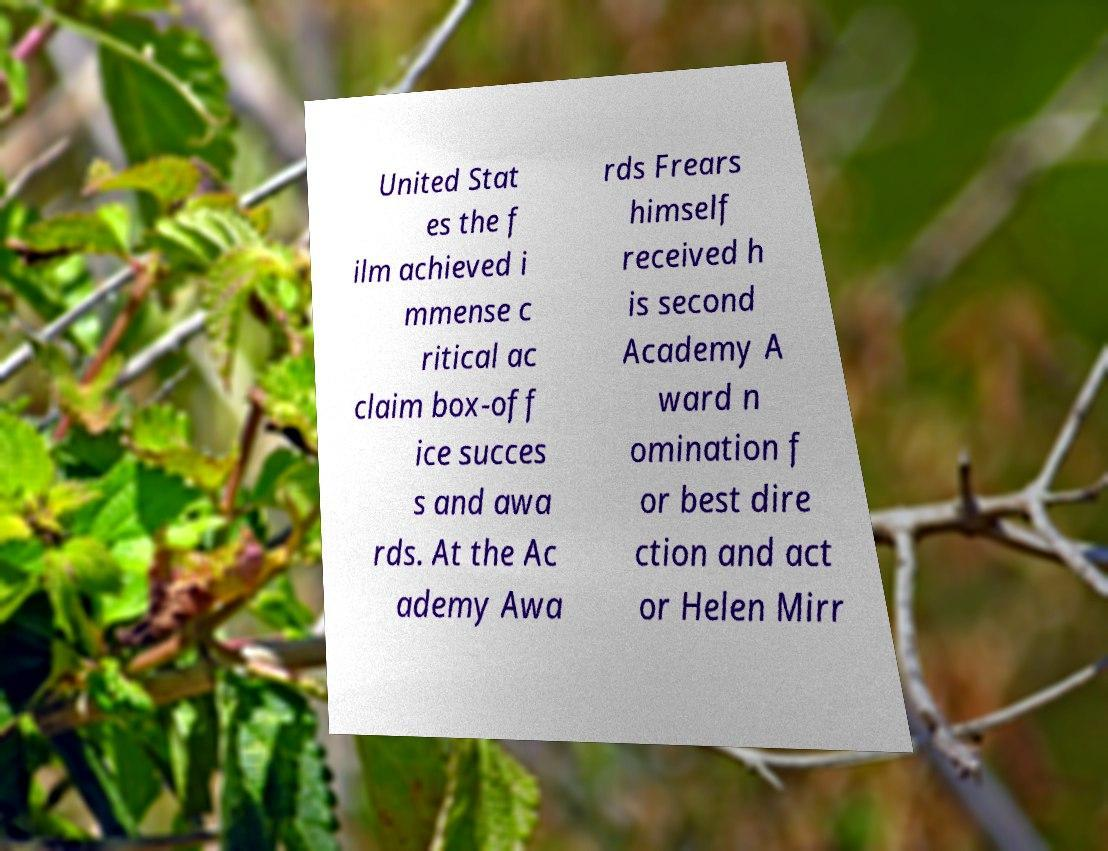Can you accurately transcribe the text from the provided image for me? United Stat es the f ilm achieved i mmense c ritical ac claim box-off ice succes s and awa rds. At the Ac ademy Awa rds Frears himself received h is second Academy A ward n omination f or best dire ction and act or Helen Mirr 